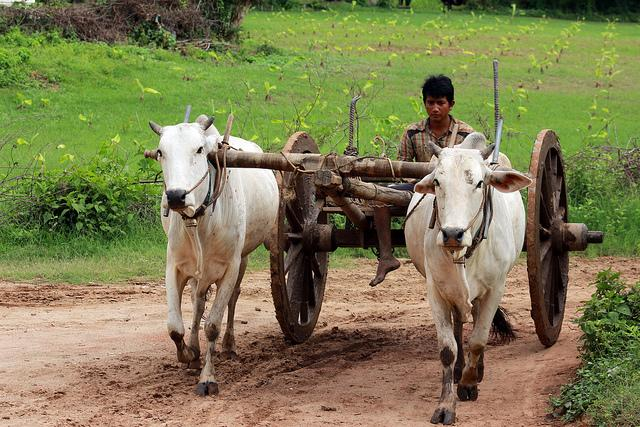What kind of animal is the cart pulled by? Please explain your reasoning. ox. These ox are pulling the cart. 